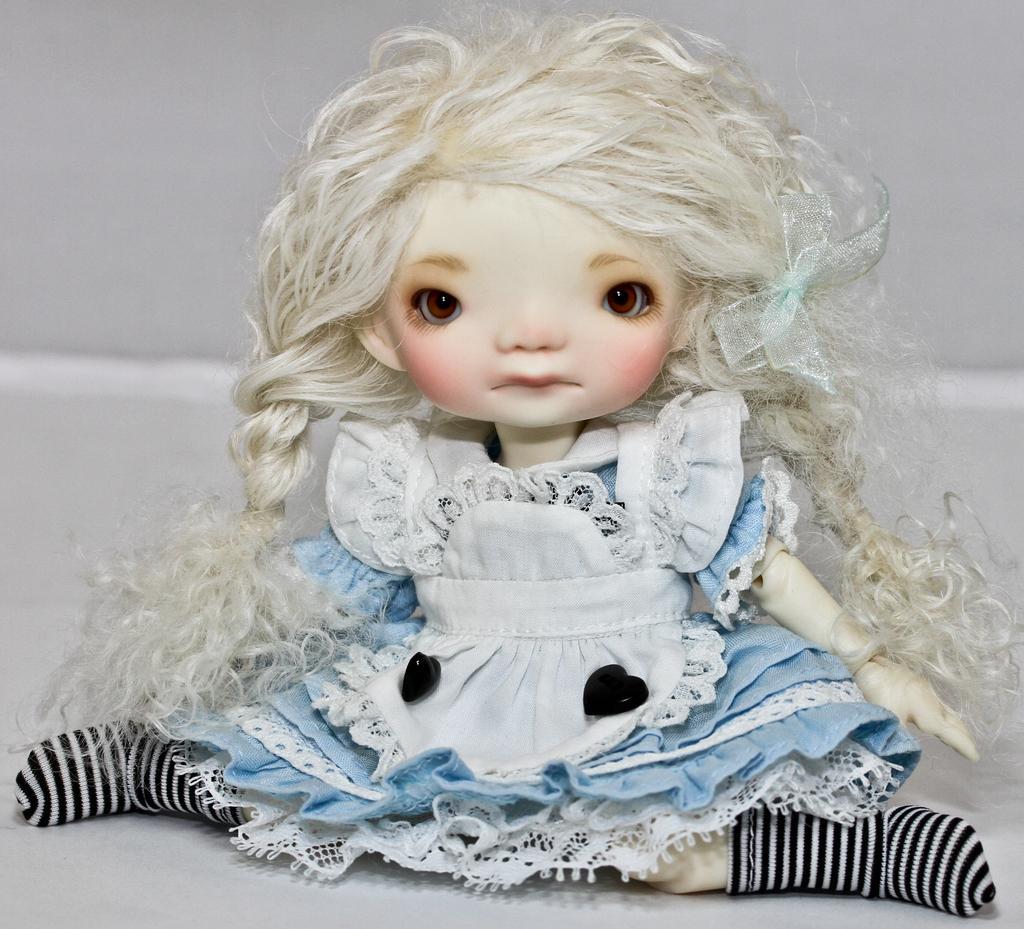Please provide a concise description of this image. In the middle of the image on the white floor there is a doll with hair, white and blue color frock and there are black and white lines socks to it. There is a white background. 